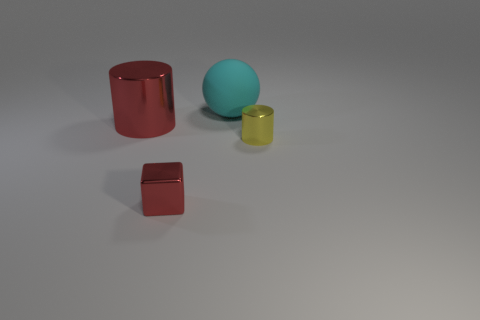Add 2 big red rubber spheres. How many objects exist? 6 Subtract all cubes. How many objects are left? 3 Add 2 big cylinders. How many big cylinders are left? 3 Add 4 yellow shiny blocks. How many yellow shiny blocks exist? 4 Subtract 0 yellow blocks. How many objects are left? 4 Subtract all small brown matte objects. Subtract all large red shiny cylinders. How many objects are left? 3 